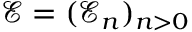<formula> <loc_0><loc_0><loc_500><loc_500>{ \mathcal { E } } = ( { \mathcal { E } _ { n } } ) _ { n > 0 }</formula> 